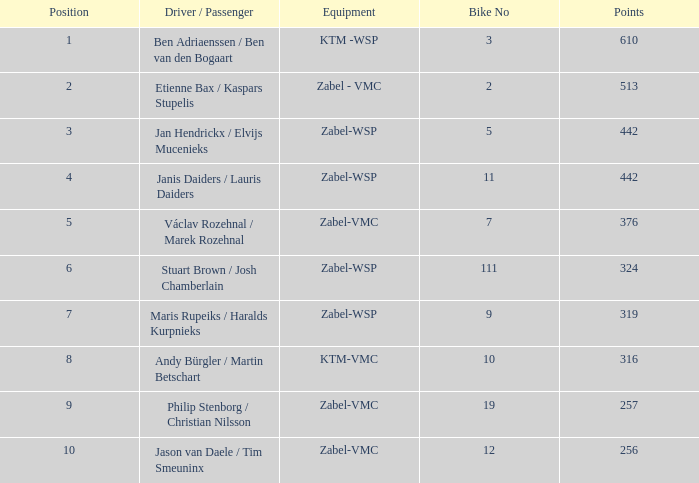What equipment has a point size larger than 256 and a position of 3? Zabel-WSP. 